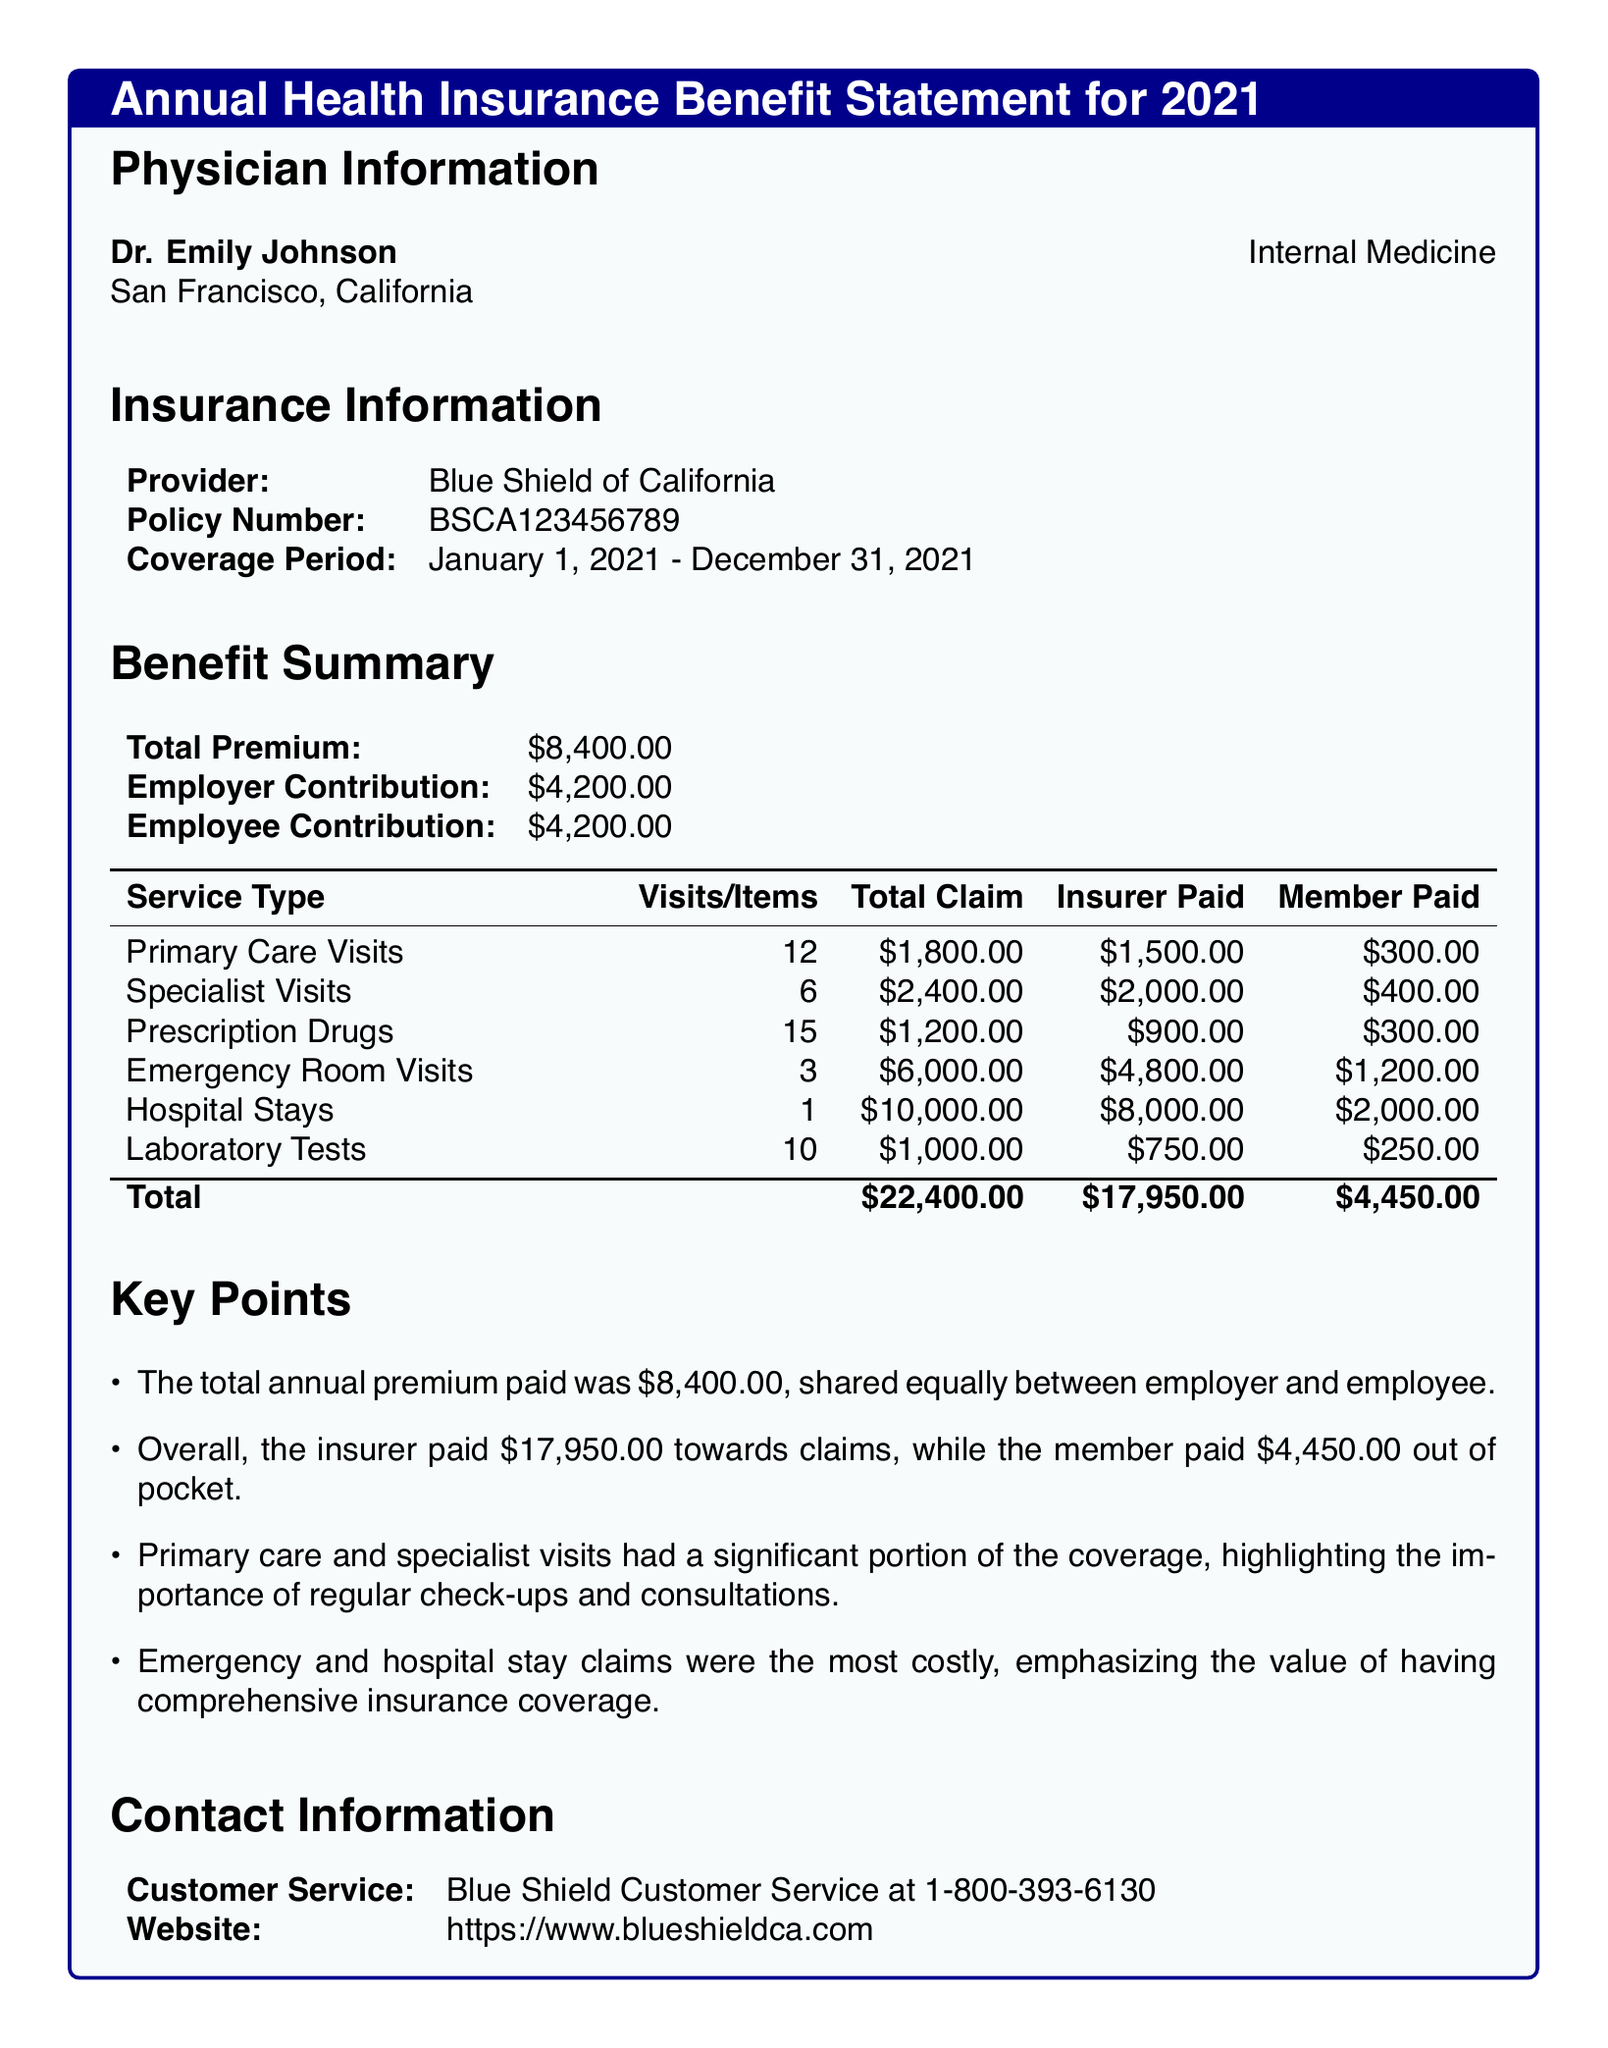What is the total premium? The total premium is listed in the Benefit Summary section of the document as $8,400.00.
Answer: $8,400.00 How much did the insurer pay towards claims? The insurer paid a total of $17,950.00 for claims, as shown in the Benefit Summary table.
Answer: $17,950.00 What is the policy number? The policy number is provided in the Insurance Information section as BSCA123456789.
Answer: BSCA123456789 How many primary care visits were there? The number of primary care visits is noted in the breakdown table as 12.
Answer: 12 What was the member’s contribution for hospital stays? The member paid $2,000.00 for hospital stays, according to the Claims Breakdown table.
Answer: $2,000.00 What is the duration of the coverage period? The coverage period is January 1, 2021 - December 31, 2021, as stated in the Insurance Information section.
Answer: January 1, 2021 - December 31, 2021 What service type had the highest total claim? The service type with the highest total claim is Emergency Room Visits, which totaled $6,000.00.
Answer: Emergency Room Visits How much did the employee contribute? The employee contribution is specified in the Benefit Summary as $4,200.00.
Answer: $4,200.00 What is the contact number for customer service? The contact number for customer service is provided as 1-800-393-6130 in the Contact Information section.
Answer: 1-800-393-6130 